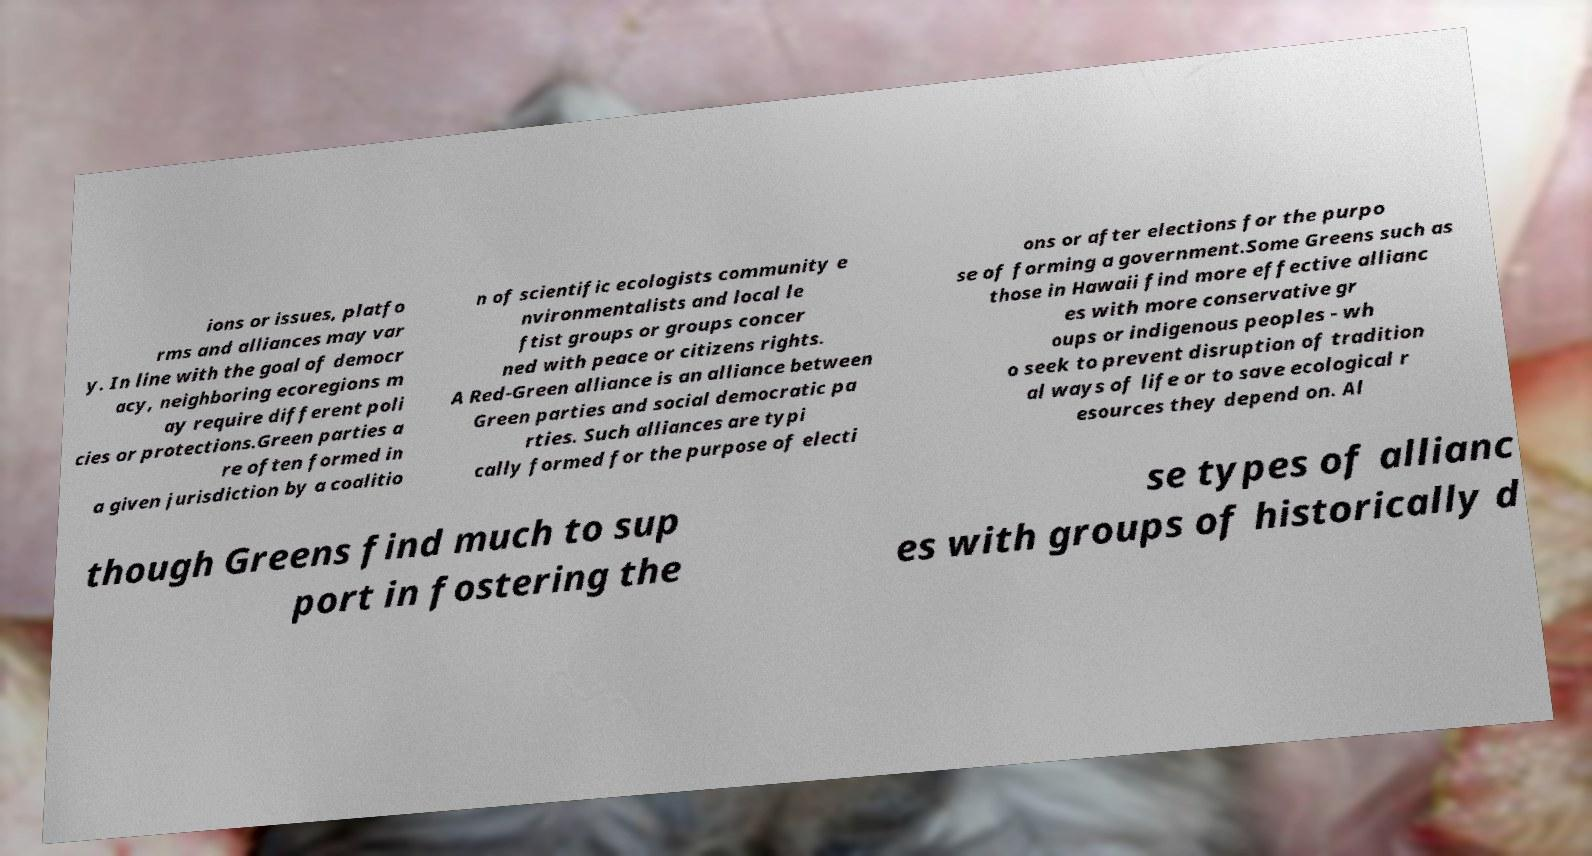Please read and relay the text visible in this image. What does it say? ions or issues, platfo rms and alliances may var y. In line with the goal of democr acy, neighboring ecoregions m ay require different poli cies or protections.Green parties a re often formed in a given jurisdiction by a coalitio n of scientific ecologists community e nvironmentalists and local le ftist groups or groups concer ned with peace or citizens rights. A Red-Green alliance is an alliance between Green parties and social democratic pa rties. Such alliances are typi cally formed for the purpose of electi ons or after elections for the purpo se of forming a government.Some Greens such as those in Hawaii find more effective allianc es with more conservative gr oups or indigenous peoples - wh o seek to prevent disruption of tradition al ways of life or to save ecological r esources they depend on. Al though Greens find much to sup port in fostering the se types of allianc es with groups of historically d 